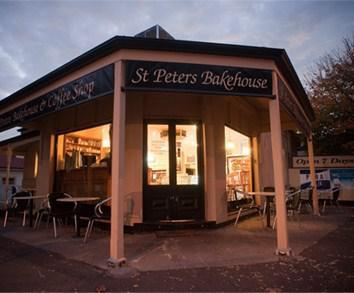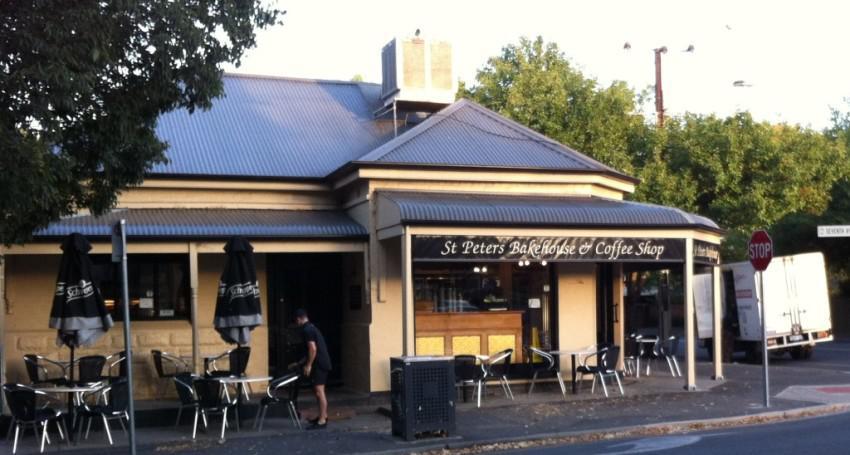The first image is the image on the left, the second image is the image on the right. Given the left and right images, does the statement "We can see the outdoor seats to the restaurant." hold true? Answer yes or no. Yes. 